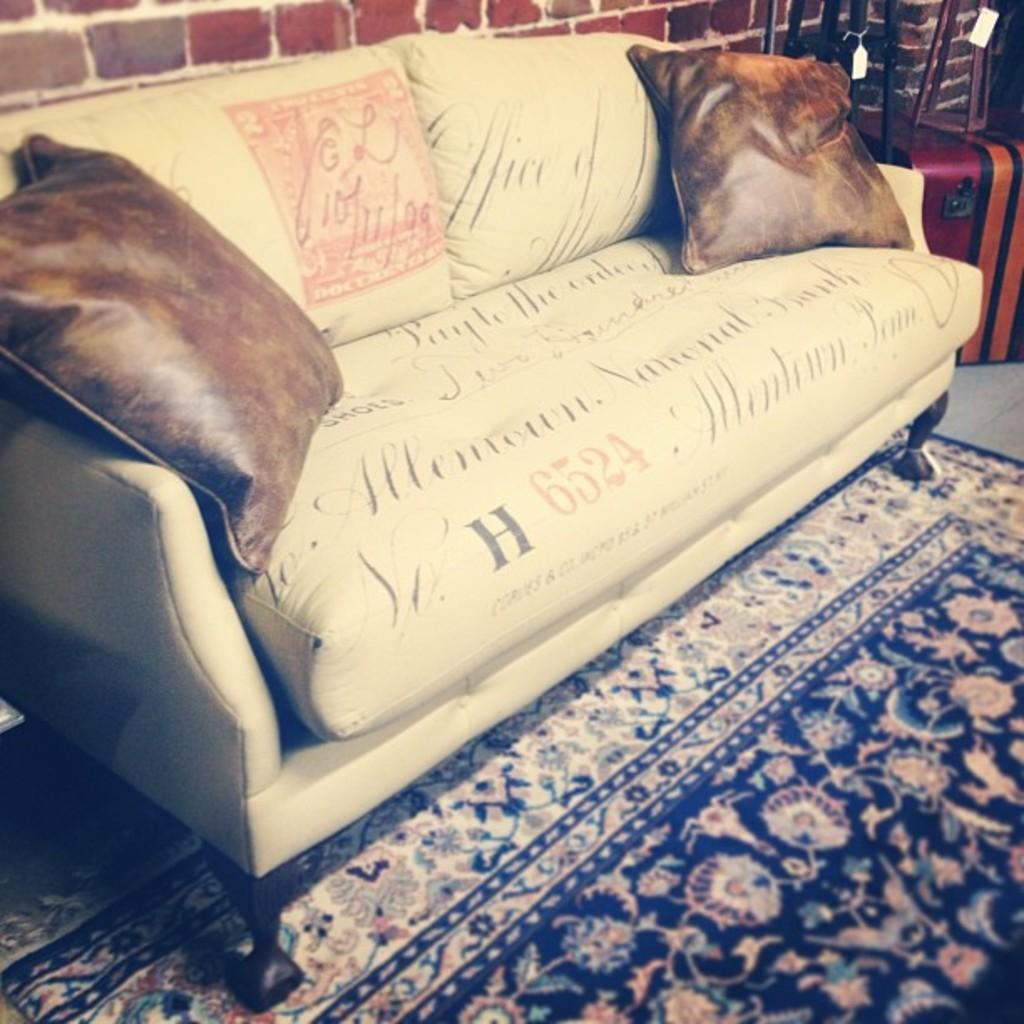What type of furniture is in the image? There is a sofa in the image. What is on the sofa? The sofa has pillows on it. What is on the floor in the image? There is a carpet on the floor. What can be seen in the background of the image? There is a wall visible in the background, and there are objects with tags in the background. What advice is being given by the eggs in the image? There are no eggs present in the image, so no advice can be given by them. 